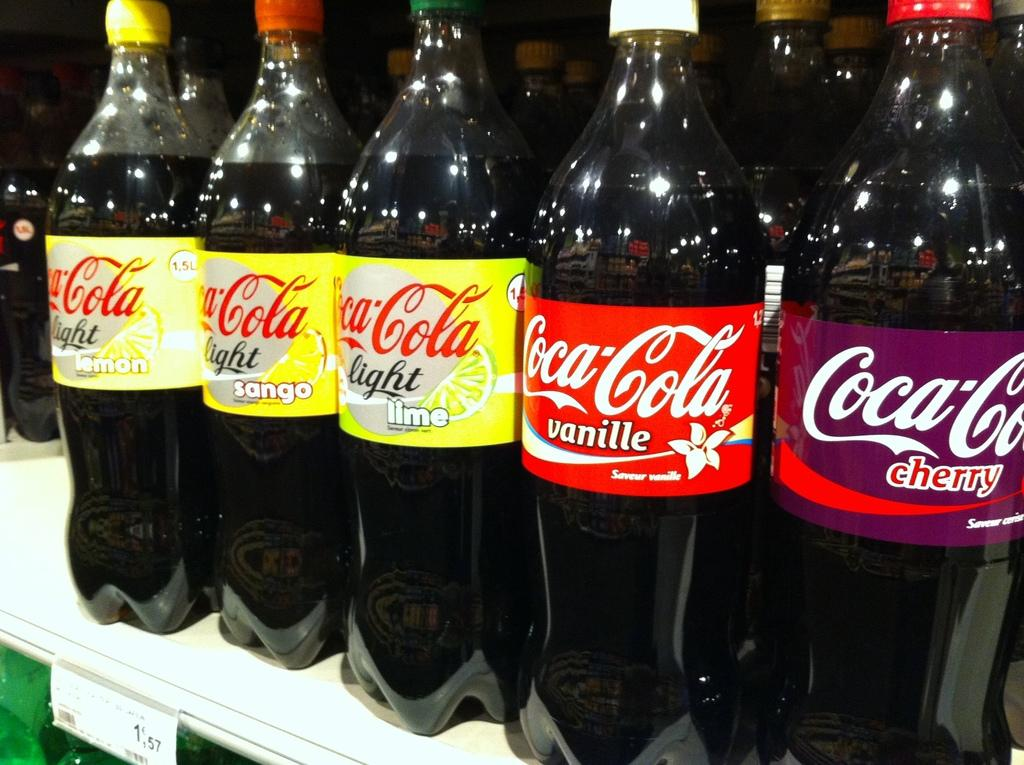What is the main subject of the image? The main subject of the image is a bunch of coke bottles. Where are the coke bottles located in the image? The coke bottles are on a stand. What type of wrench is being used to tighten the ship's thread in the image? There is no wrench, ship, or thread present in the image. The image only features a bunch of coke bottles on a stand. 